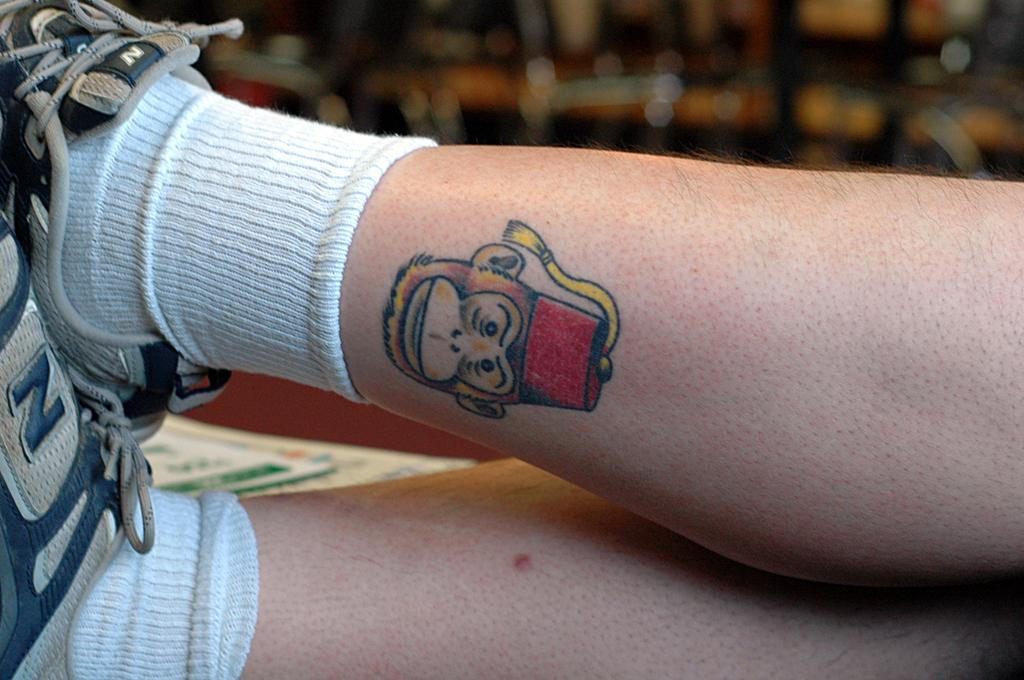What body part of a person is visible in the image? There are a person's legs in the image. What type of footwear is the person wearing? The person is wearing shoes. Are there any additional clothing items visible on the person's legs? Yes, the person is wearing socks. What can be seen in the image besides the person's legs? There is a symbol in the image, and the background contains some objects. How would you describe the background of the image? The background is blurry. What type of substance is the person holding in the image? There is no substance visible in the image; only the person's legs, shoes, socks, a symbol, and background objects are present. Can you tell me how many pickles are in the person's hand in the image? There are no pickles present in the image. 